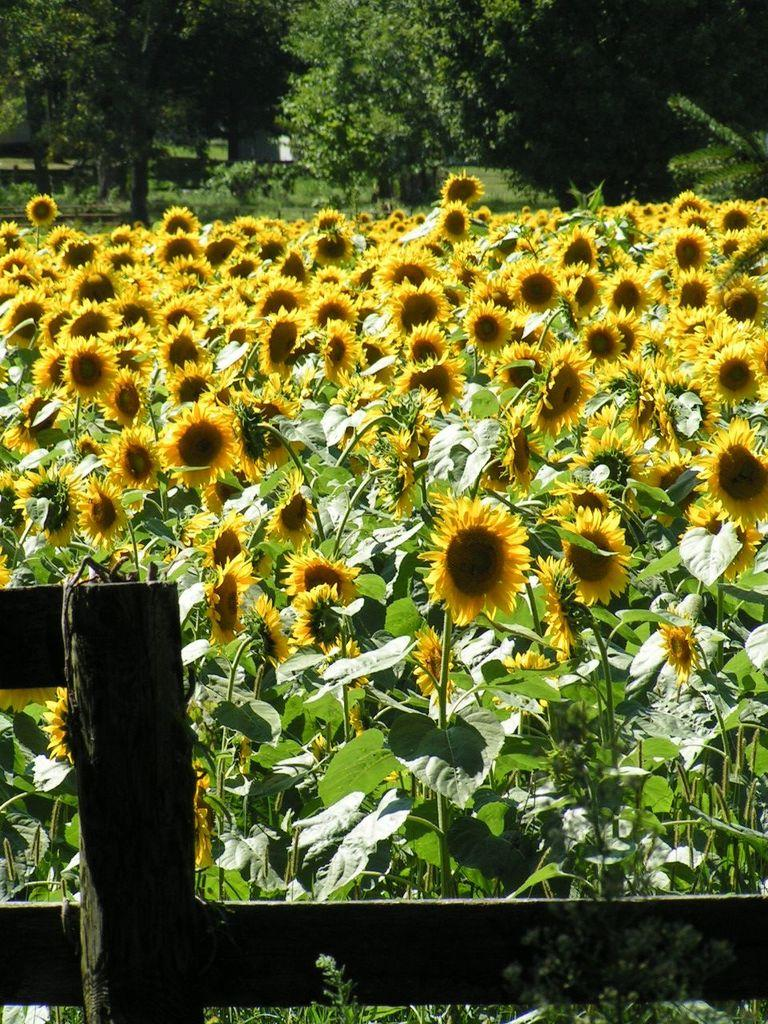What is the main structure visible in the image? There is a fence in the image. What can be seen behind the fence? There are plants and flowers behind the fence. What type of vegetation is visible in the background of the image? There are trees in the background of the image. How many rings are hanging on the fence in the image? There are no rings hanging on the fence in the image. What type of jeans are the plants wearing in the image? The plants in the image are not wearing jeans, as plants do not wear clothing. 